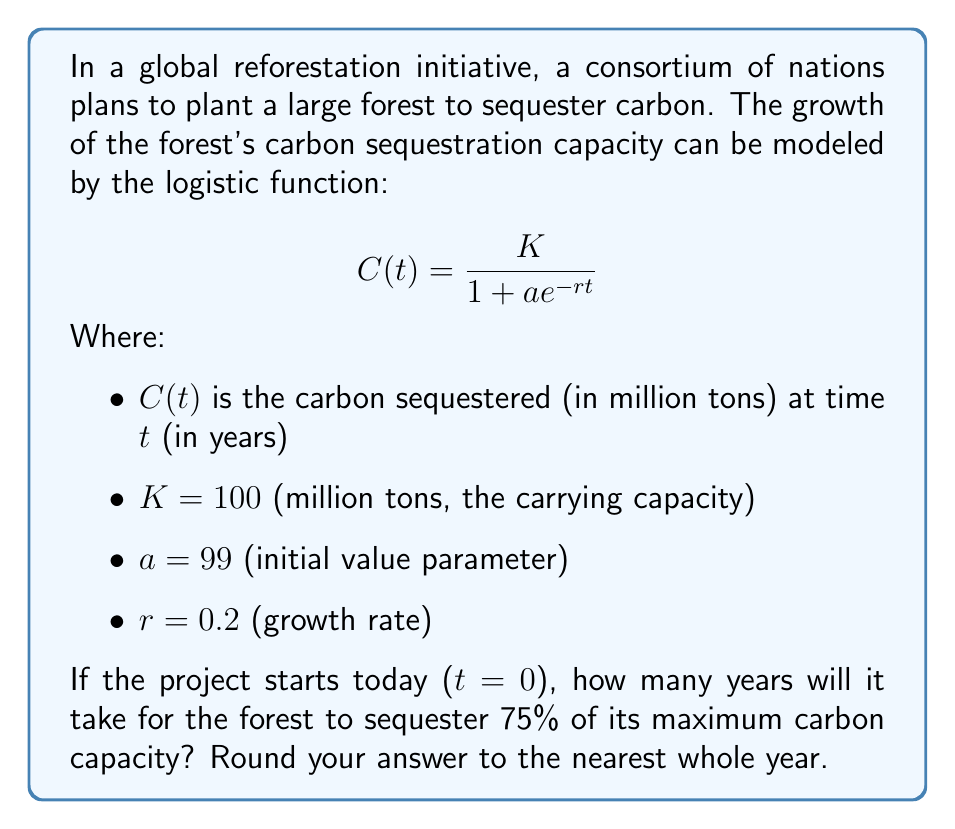What is the answer to this math problem? To solve this problem, we need to follow these steps:

1) First, we need to determine the target amount of carbon sequestered. Since we're looking for 75% of the maximum capacity (K), our target is:

   Target = 0.75 * K = 0.75 * 100 = 75 million tons

2) Now, we need to solve the equation:

   $$75 = \frac{100}{1 + 99e^{-0.2t}}$$

3) Let's solve this step-by-step:
   
   $$75(1 + 99e^{-0.2t}) = 100$$
   $$75 + 7425e^{-0.2t} = 100$$
   $$7425e^{-0.2t} = 25$$
   $$e^{-0.2t} = \frac{25}{7425} = \frac{1}{297}$$

4) Now we can take the natural log of both sides:

   $$-0.2t = \ln(\frac{1}{297})$$
   $$t = -\frac{\ln(\frac{1}{297})}{0.2}$$

5) Calculate the result:
   
   $$t = -\frac{\ln(1/297)}{0.2} = \frac{\ln(297)}{0.2} \approx 28.48$$

6) Rounding to the nearest whole year:

   t ≈ 28 years
Answer: 28 years 